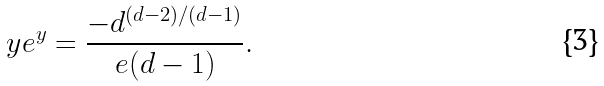<formula> <loc_0><loc_0><loc_500><loc_500>y e ^ { y } = \frac { - d ^ { ( d - 2 ) / ( d - 1 ) } } { e ( d - 1 ) } .</formula> 